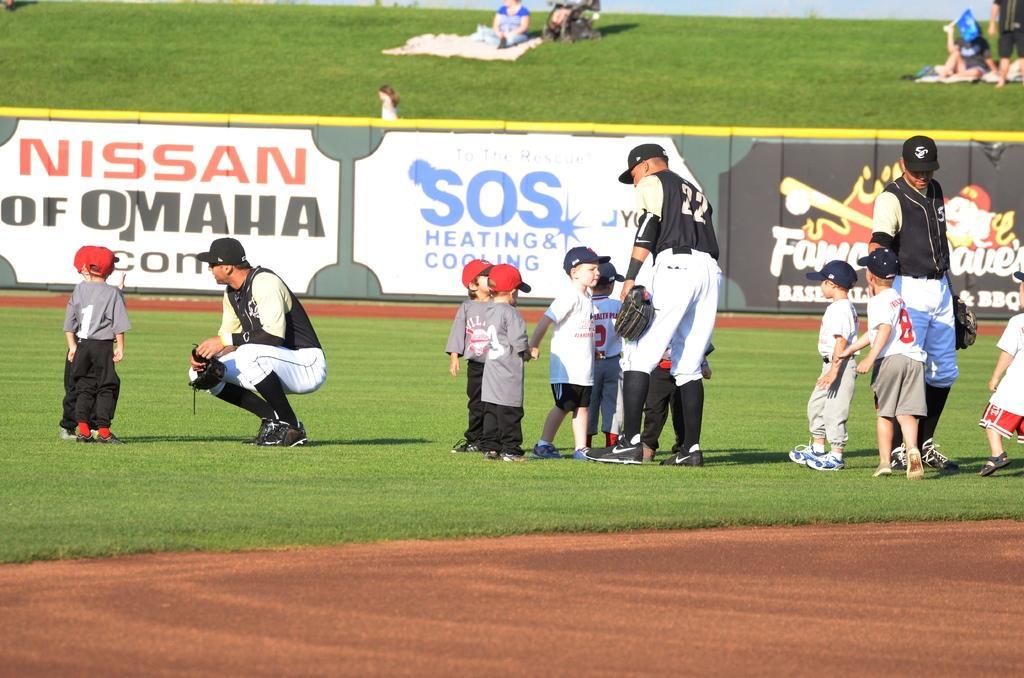In one or two sentences, can you explain what this image depicts? In the foreground of this image, there is a man squatting on the grass, few kids and men standing on the grass and the boundary banner wall. In the background, there are few persons standing and sitting on the grass. 